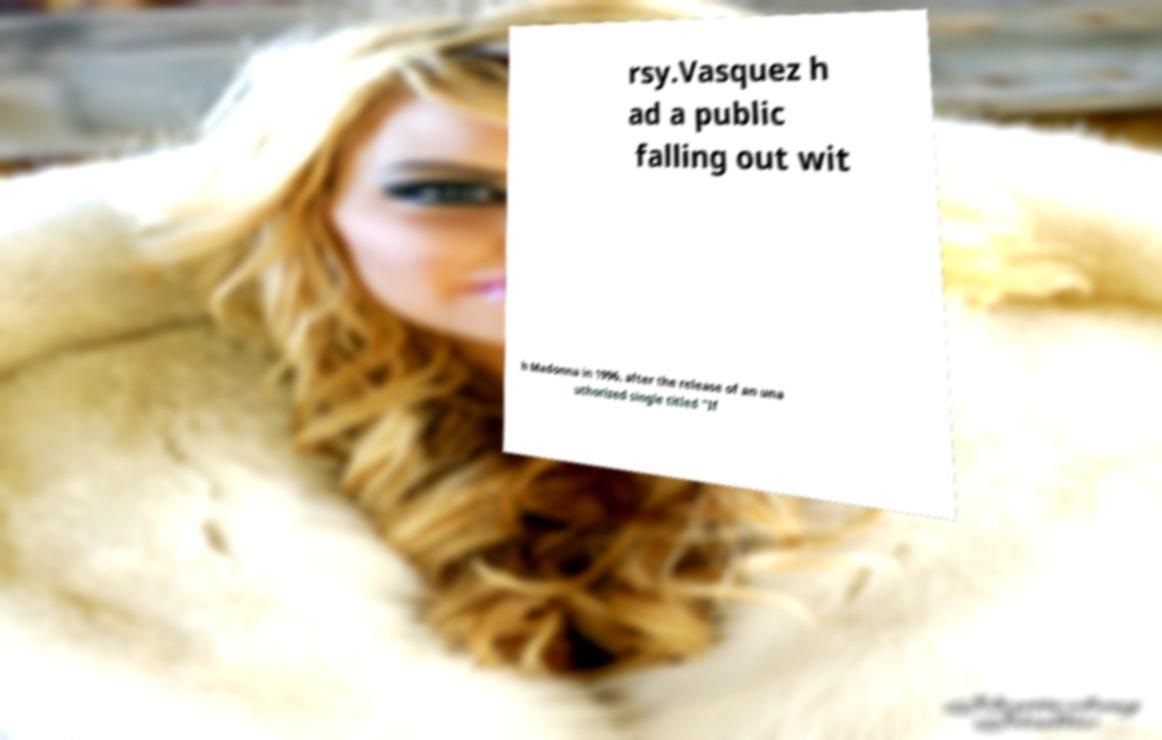Please identify and transcribe the text found in this image. rsy.Vasquez h ad a public falling out wit h Madonna in 1996, after the release of an una uthorized single titled "If 